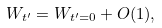<formula> <loc_0><loc_0><loc_500><loc_500>W _ { t ^ { \prime } } = W _ { t ^ { \prime } = 0 } + O ( 1 ) ,</formula> 